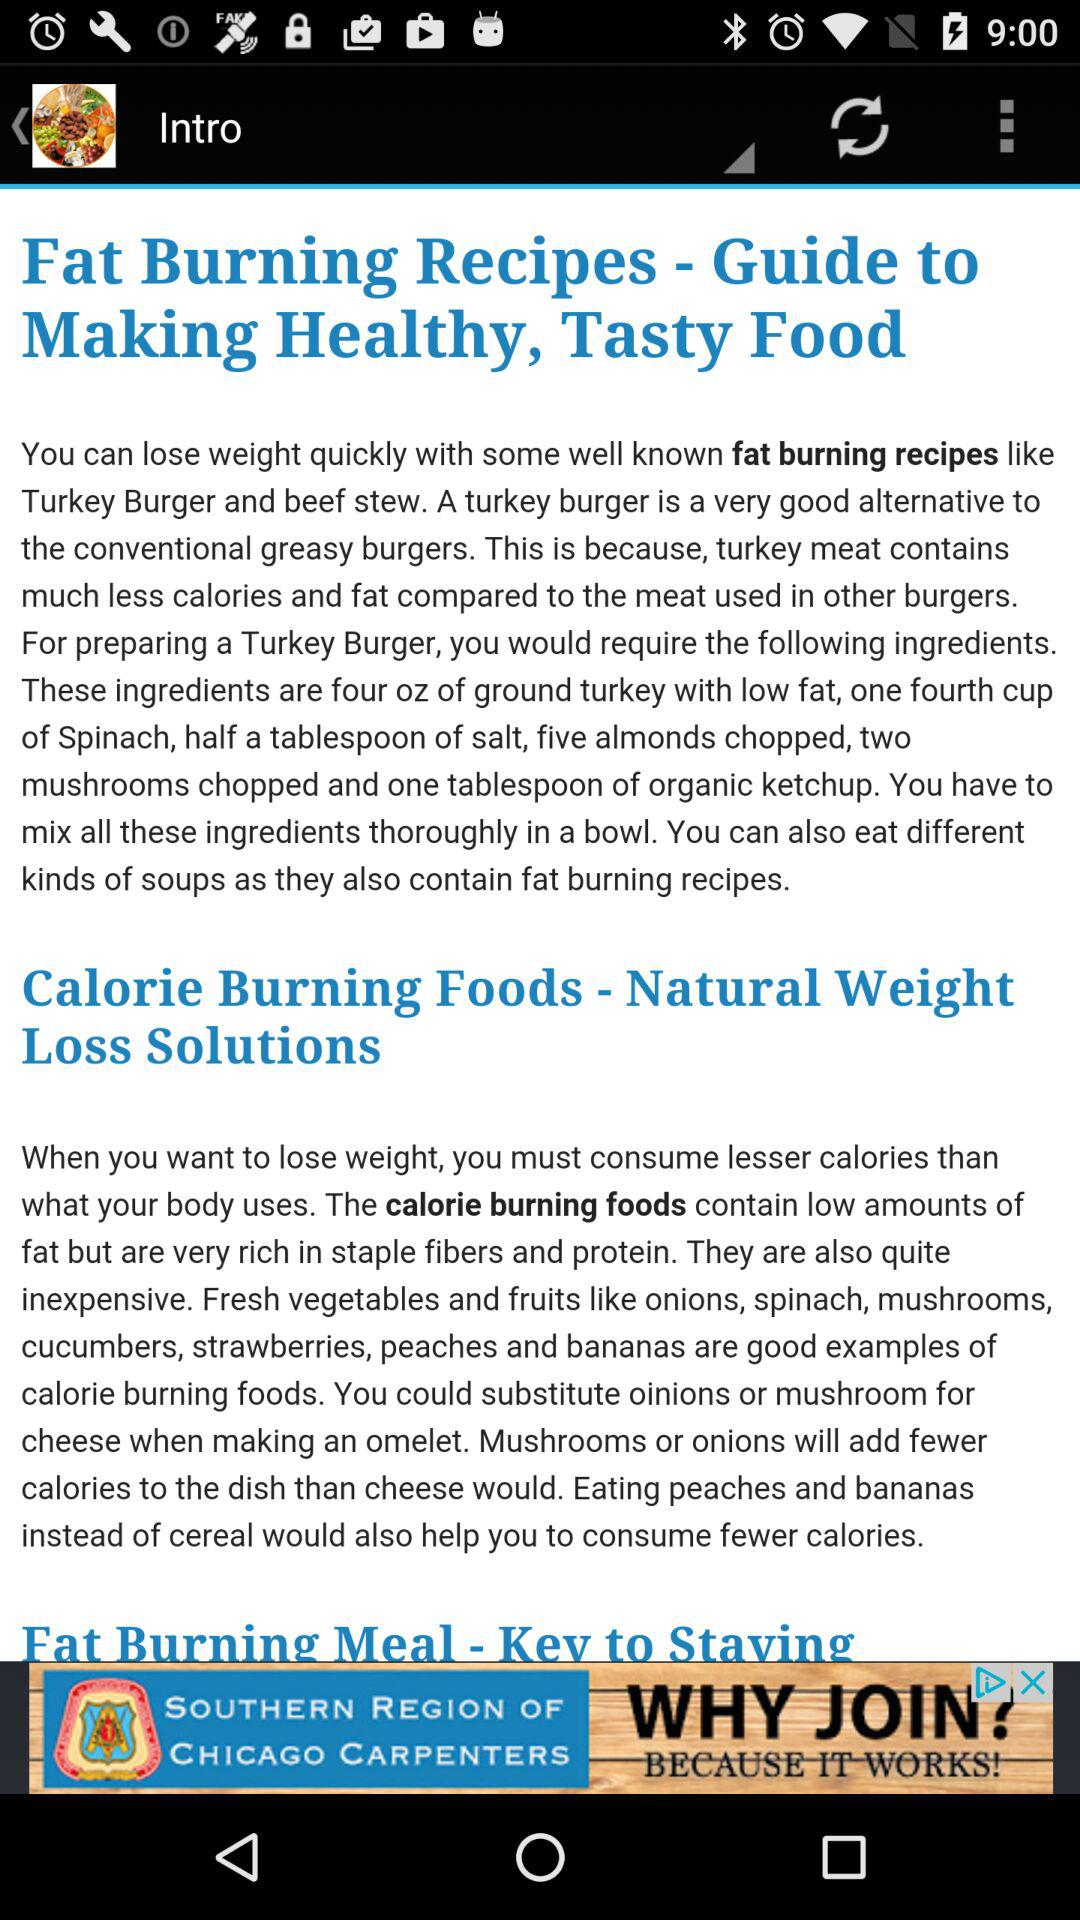What are the ingredients for preparing turkey burgers? The ingredients are oz of ground turkey with low fat, one fourth cup of Spinach, half a tablespoon of salt, five almonds chopped, two mushrooms chopped and one tablespoon of organic ketchup. 